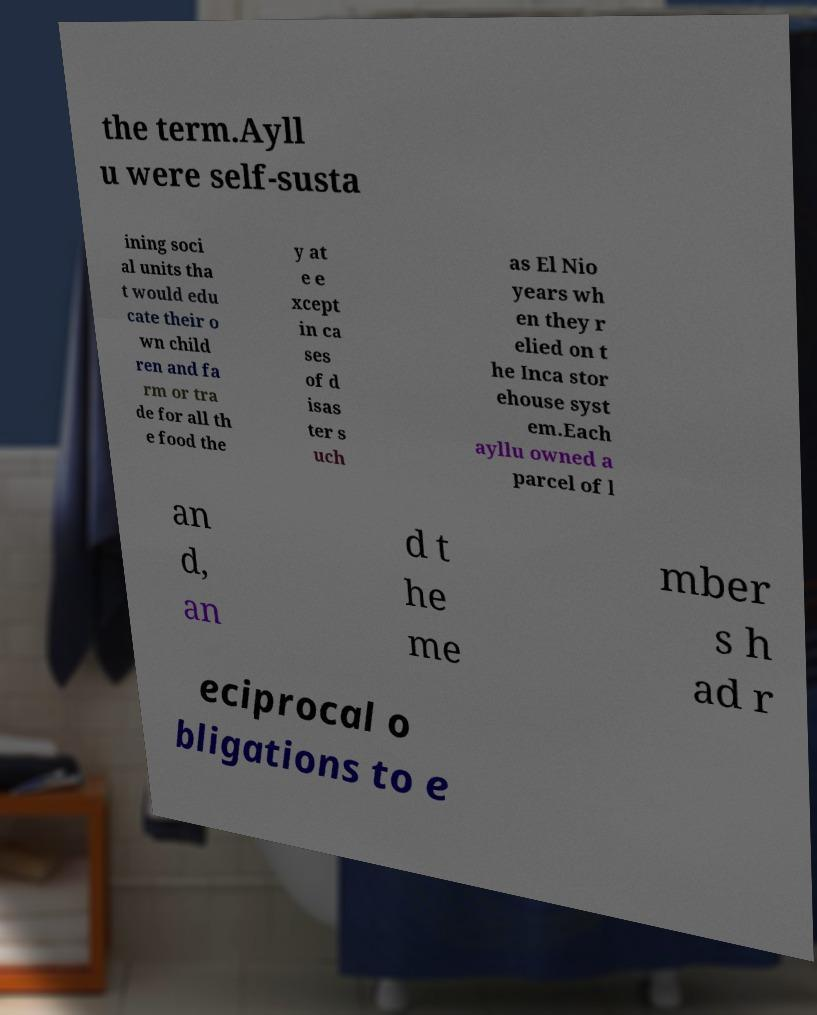Can you accurately transcribe the text from the provided image for me? the term.Ayll u were self-susta ining soci al units tha t would edu cate their o wn child ren and fa rm or tra de for all th e food the y at e e xcept in ca ses of d isas ter s uch as El Nio years wh en they r elied on t he Inca stor ehouse syst em.Each ayllu owned a parcel of l an d, an d t he me mber s h ad r eciprocal o bligations to e 